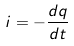Convert formula to latex. <formula><loc_0><loc_0><loc_500><loc_500>i = - \frac { d q } { d t }</formula> 